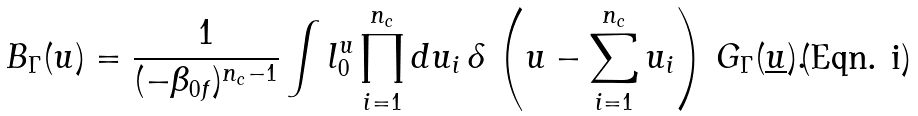<formula> <loc_0><loc_0><loc_500><loc_500>B _ { \Gamma } ( u ) = \frac { 1 } { ( - \beta _ { 0 f } ) ^ { n _ { c } - 1 } } \int l _ { 0 } ^ { u } \prod _ { i = 1 } ^ { n _ { c } } d u _ { i } \, \delta \, \left ( u - \sum _ { i = 1 } ^ { n _ { c } } u _ { i } \right ) \, G _ { \Gamma } ( \underline { u } ) .</formula> 